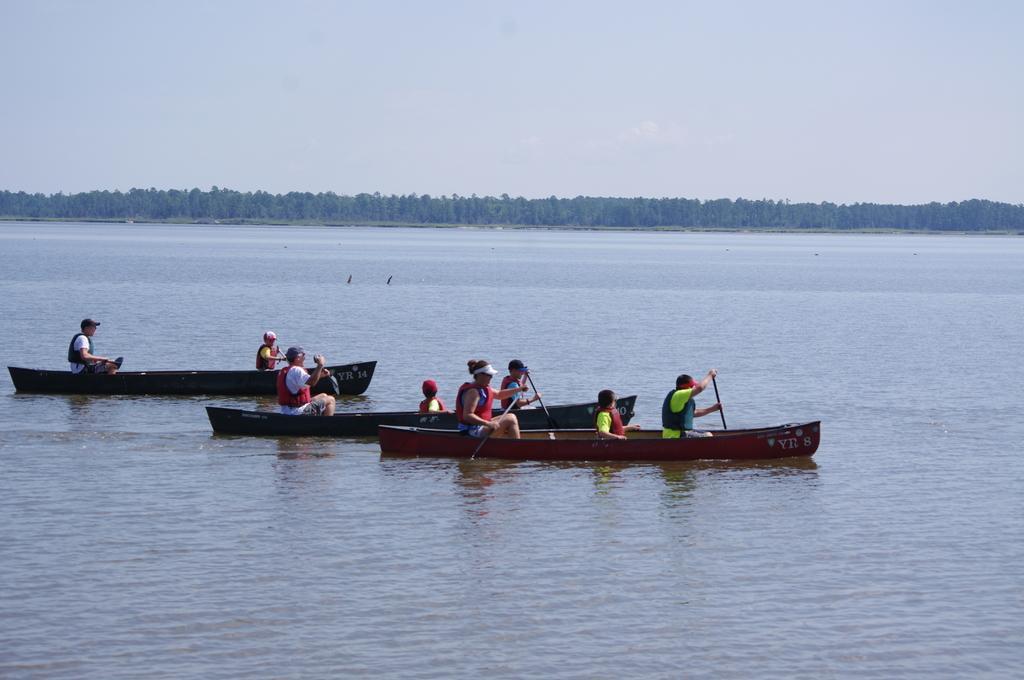Can you describe this image briefly? In this image I can see there are some people sailing the boats on the water at the back there are so many trees. 